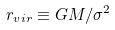<formula> <loc_0><loc_0><loc_500><loc_500>r _ { v i r } \equiv G M / \sigma ^ { 2 }</formula> 